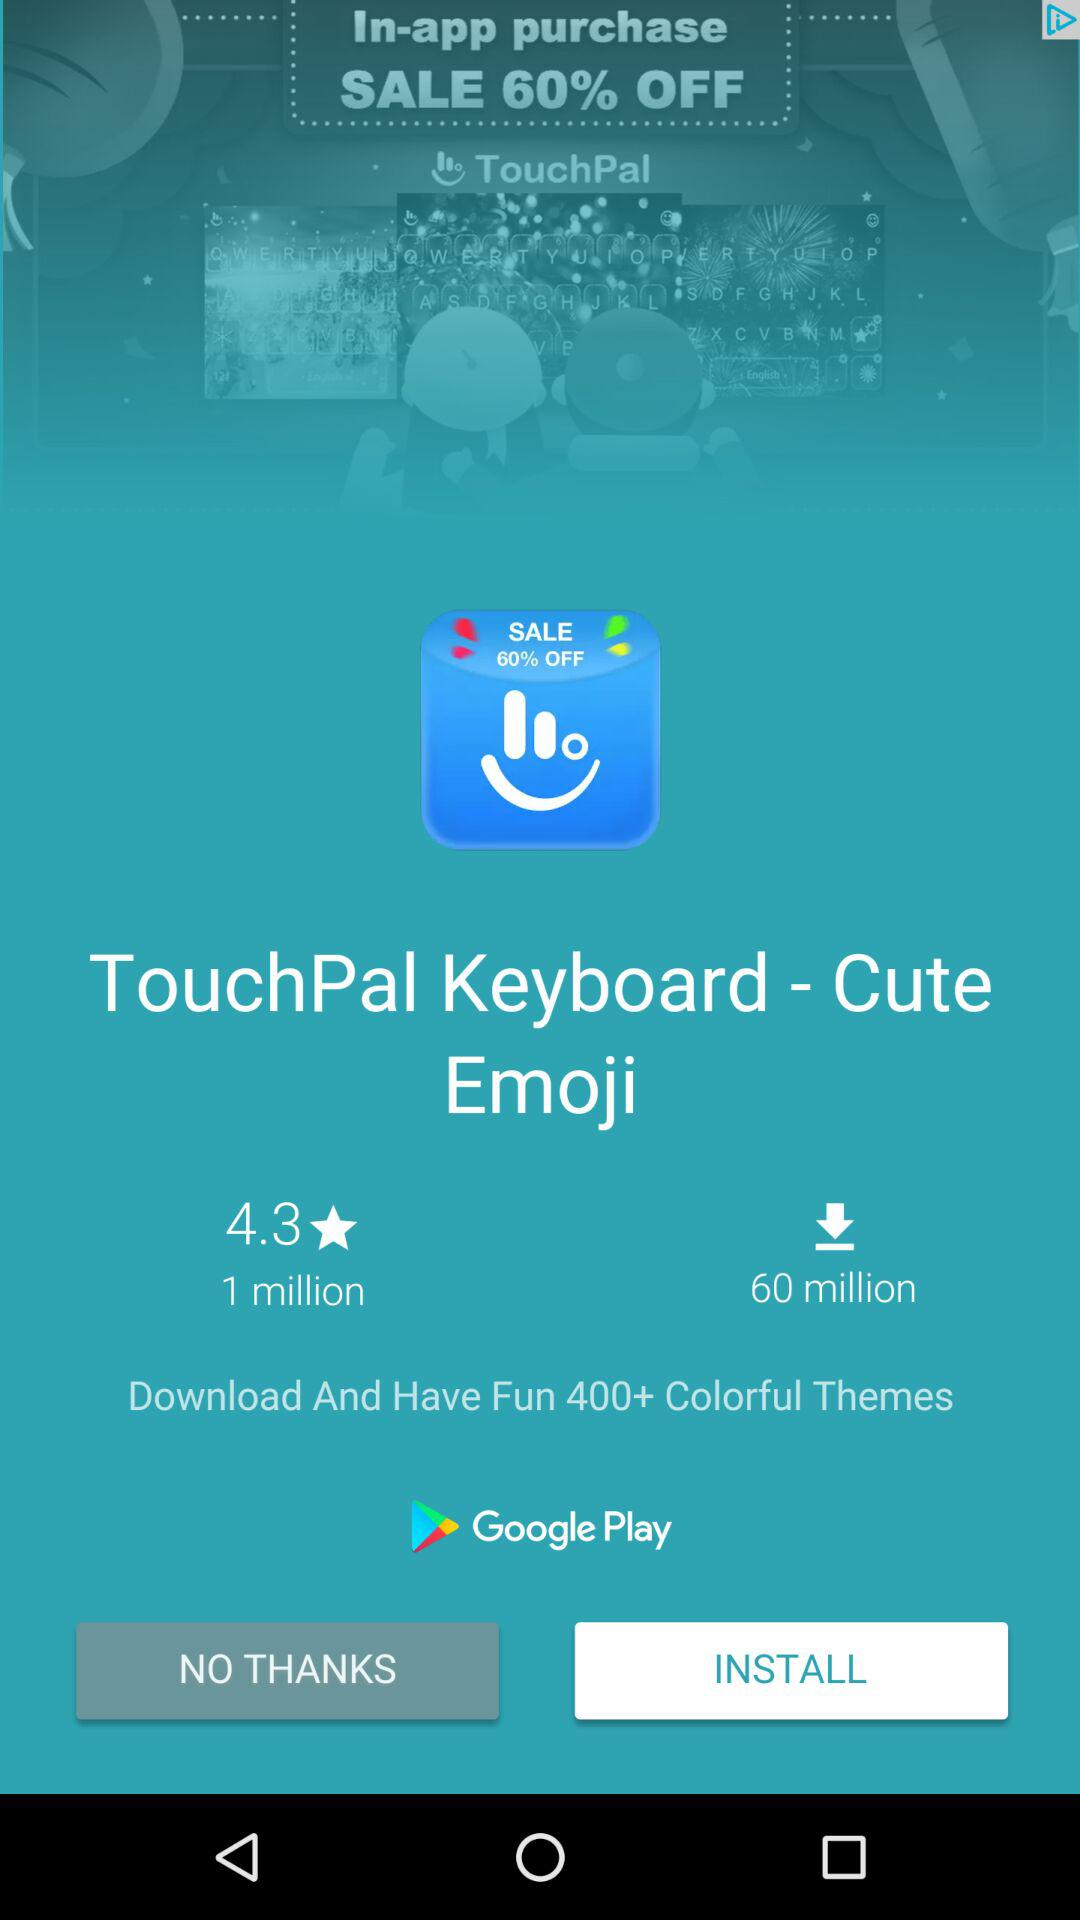How many more downloads does the app have than reviews?
Answer the question using a single word or phrase. 59 million 